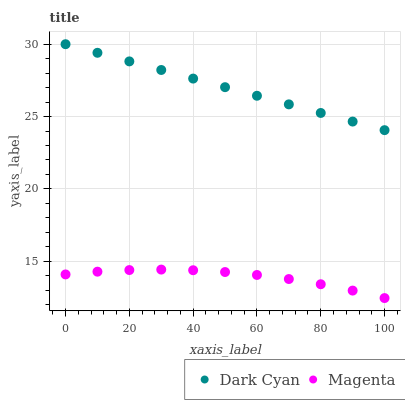Does Magenta have the minimum area under the curve?
Answer yes or no. Yes. Does Dark Cyan have the maximum area under the curve?
Answer yes or no. Yes. Does Magenta have the maximum area under the curve?
Answer yes or no. No. Is Dark Cyan the smoothest?
Answer yes or no. Yes. Is Magenta the roughest?
Answer yes or no. Yes. Is Magenta the smoothest?
Answer yes or no. No. Does Magenta have the lowest value?
Answer yes or no. Yes. Does Dark Cyan have the highest value?
Answer yes or no. Yes. Does Magenta have the highest value?
Answer yes or no. No. Is Magenta less than Dark Cyan?
Answer yes or no. Yes. Is Dark Cyan greater than Magenta?
Answer yes or no. Yes. Does Magenta intersect Dark Cyan?
Answer yes or no. No. 